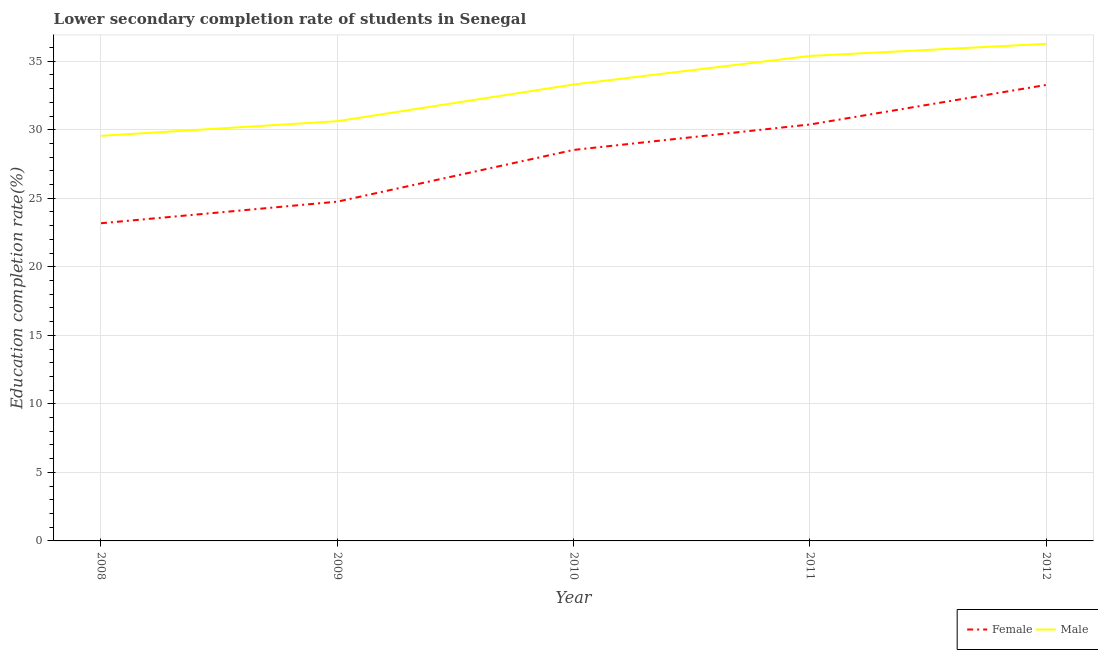How many different coloured lines are there?
Your answer should be compact. 2. Does the line corresponding to education completion rate of female students intersect with the line corresponding to education completion rate of male students?
Keep it short and to the point. No. What is the education completion rate of male students in 2008?
Give a very brief answer. 29.55. Across all years, what is the maximum education completion rate of male students?
Your response must be concise. 36.27. Across all years, what is the minimum education completion rate of male students?
Offer a terse response. 29.55. In which year was the education completion rate of female students maximum?
Your answer should be very brief. 2012. In which year was the education completion rate of female students minimum?
Provide a short and direct response. 2008. What is the total education completion rate of male students in the graph?
Offer a terse response. 165.12. What is the difference between the education completion rate of female students in 2009 and that in 2010?
Your answer should be compact. -3.77. What is the difference between the education completion rate of male students in 2011 and the education completion rate of female students in 2009?
Provide a succinct answer. 10.63. What is the average education completion rate of female students per year?
Ensure brevity in your answer.  28.02. In the year 2008, what is the difference between the education completion rate of male students and education completion rate of female students?
Keep it short and to the point. 6.38. In how many years, is the education completion rate of female students greater than 5 %?
Give a very brief answer. 5. What is the ratio of the education completion rate of female students in 2008 to that in 2012?
Your answer should be compact. 0.7. Is the difference between the education completion rate of male students in 2009 and 2012 greater than the difference between the education completion rate of female students in 2009 and 2012?
Ensure brevity in your answer.  Yes. What is the difference between the highest and the second highest education completion rate of female students?
Keep it short and to the point. 2.89. What is the difference between the highest and the lowest education completion rate of male students?
Offer a terse response. 6.71. Does the education completion rate of female students monotonically increase over the years?
Ensure brevity in your answer.  Yes. Is the education completion rate of male students strictly greater than the education completion rate of female students over the years?
Keep it short and to the point. Yes. How many years are there in the graph?
Your answer should be compact. 5. Are the values on the major ticks of Y-axis written in scientific E-notation?
Give a very brief answer. No. Where does the legend appear in the graph?
Your answer should be compact. Bottom right. How many legend labels are there?
Make the answer very short. 2. How are the legend labels stacked?
Your answer should be very brief. Horizontal. What is the title of the graph?
Give a very brief answer. Lower secondary completion rate of students in Senegal. What is the label or title of the X-axis?
Offer a terse response. Year. What is the label or title of the Y-axis?
Keep it short and to the point. Education completion rate(%). What is the Education completion rate(%) in Female in 2008?
Your answer should be compact. 23.18. What is the Education completion rate(%) in Male in 2008?
Your answer should be compact. 29.55. What is the Education completion rate(%) in Female in 2009?
Ensure brevity in your answer.  24.75. What is the Education completion rate(%) of Male in 2009?
Your response must be concise. 30.62. What is the Education completion rate(%) in Female in 2010?
Your answer should be compact. 28.53. What is the Education completion rate(%) in Male in 2010?
Give a very brief answer. 33.3. What is the Education completion rate(%) in Female in 2011?
Provide a short and direct response. 30.38. What is the Education completion rate(%) in Male in 2011?
Your answer should be compact. 35.38. What is the Education completion rate(%) in Female in 2012?
Give a very brief answer. 33.27. What is the Education completion rate(%) in Male in 2012?
Give a very brief answer. 36.27. Across all years, what is the maximum Education completion rate(%) in Female?
Your answer should be compact. 33.27. Across all years, what is the maximum Education completion rate(%) of Male?
Keep it short and to the point. 36.27. Across all years, what is the minimum Education completion rate(%) of Female?
Give a very brief answer. 23.18. Across all years, what is the minimum Education completion rate(%) of Male?
Make the answer very short. 29.55. What is the total Education completion rate(%) in Female in the graph?
Provide a succinct answer. 140.1. What is the total Education completion rate(%) in Male in the graph?
Offer a very short reply. 165.12. What is the difference between the Education completion rate(%) in Female in 2008 and that in 2009?
Your answer should be compact. -1.57. What is the difference between the Education completion rate(%) in Male in 2008 and that in 2009?
Your answer should be very brief. -1.07. What is the difference between the Education completion rate(%) of Female in 2008 and that in 2010?
Offer a terse response. -5.35. What is the difference between the Education completion rate(%) in Male in 2008 and that in 2010?
Provide a succinct answer. -3.75. What is the difference between the Education completion rate(%) of Female in 2008 and that in 2011?
Your answer should be compact. -7.21. What is the difference between the Education completion rate(%) of Male in 2008 and that in 2011?
Your answer should be very brief. -5.83. What is the difference between the Education completion rate(%) of Female in 2008 and that in 2012?
Offer a terse response. -10.09. What is the difference between the Education completion rate(%) in Male in 2008 and that in 2012?
Make the answer very short. -6.71. What is the difference between the Education completion rate(%) of Female in 2009 and that in 2010?
Ensure brevity in your answer.  -3.77. What is the difference between the Education completion rate(%) of Male in 2009 and that in 2010?
Your response must be concise. -2.68. What is the difference between the Education completion rate(%) in Female in 2009 and that in 2011?
Make the answer very short. -5.63. What is the difference between the Education completion rate(%) in Male in 2009 and that in 2011?
Your answer should be very brief. -4.76. What is the difference between the Education completion rate(%) of Female in 2009 and that in 2012?
Your response must be concise. -8.52. What is the difference between the Education completion rate(%) of Male in 2009 and that in 2012?
Offer a terse response. -5.64. What is the difference between the Education completion rate(%) of Female in 2010 and that in 2011?
Give a very brief answer. -1.86. What is the difference between the Education completion rate(%) in Male in 2010 and that in 2011?
Offer a very short reply. -2.08. What is the difference between the Education completion rate(%) of Female in 2010 and that in 2012?
Provide a short and direct response. -4.74. What is the difference between the Education completion rate(%) in Male in 2010 and that in 2012?
Give a very brief answer. -2.97. What is the difference between the Education completion rate(%) in Female in 2011 and that in 2012?
Ensure brevity in your answer.  -2.89. What is the difference between the Education completion rate(%) of Male in 2011 and that in 2012?
Give a very brief answer. -0.88. What is the difference between the Education completion rate(%) of Female in 2008 and the Education completion rate(%) of Male in 2009?
Keep it short and to the point. -7.45. What is the difference between the Education completion rate(%) of Female in 2008 and the Education completion rate(%) of Male in 2010?
Make the answer very short. -10.12. What is the difference between the Education completion rate(%) in Female in 2008 and the Education completion rate(%) in Male in 2011?
Offer a terse response. -12.21. What is the difference between the Education completion rate(%) in Female in 2008 and the Education completion rate(%) in Male in 2012?
Your response must be concise. -13.09. What is the difference between the Education completion rate(%) in Female in 2009 and the Education completion rate(%) in Male in 2010?
Provide a short and direct response. -8.55. What is the difference between the Education completion rate(%) of Female in 2009 and the Education completion rate(%) of Male in 2011?
Your answer should be very brief. -10.63. What is the difference between the Education completion rate(%) in Female in 2009 and the Education completion rate(%) in Male in 2012?
Keep it short and to the point. -11.51. What is the difference between the Education completion rate(%) of Female in 2010 and the Education completion rate(%) of Male in 2011?
Offer a terse response. -6.86. What is the difference between the Education completion rate(%) in Female in 2010 and the Education completion rate(%) in Male in 2012?
Provide a short and direct response. -7.74. What is the difference between the Education completion rate(%) in Female in 2011 and the Education completion rate(%) in Male in 2012?
Your response must be concise. -5.88. What is the average Education completion rate(%) of Female per year?
Make the answer very short. 28.02. What is the average Education completion rate(%) of Male per year?
Offer a very short reply. 33.02. In the year 2008, what is the difference between the Education completion rate(%) of Female and Education completion rate(%) of Male?
Your answer should be compact. -6.38. In the year 2009, what is the difference between the Education completion rate(%) of Female and Education completion rate(%) of Male?
Your answer should be compact. -5.87. In the year 2010, what is the difference between the Education completion rate(%) in Female and Education completion rate(%) in Male?
Keep it short and to the point. -4.77. In the year 2011, what is the difference between the Education completion rate(%) in Female and Education completion rate(%) in Male?
Give a very brief answer. -5. In the year 2012, what is the difference between the Education completion rate(%) of Female and Education completion rate(%) of Male?
Your answer should be compact. -3. What is the ratio of the Education completion rate(%) in Female in 2008 to that in 2009?
Your answer should be very brief. 0.94. What is the ratio of the Education completion rate(%) in Male in 2008 to that in 2009?
Your response must be concise. 0.97. What is the ratio of the Education completion rate(%) of Female in 2008 to that in 2010?
Keep it short and to the point. 0.81. What is the ratio of the Education completion rate(%) of Male in 2008 to that in 2010?
Make the answer very short. 0.89. What is the ratio of the Education completion rate(%) of Female in 2008 to that in 2011?
Offer a terse response. 0.76. What is the ratio of the Education completion rate(%) of Male in 2008 to that in 2011?
Keep it short and to the point. 0.84. What is the ratio of the Education completion rate(%) in Female in 2008 to that in 2012?
Make the answer very short. 0.7. What is the ratio of the Education completion rate(%) of Male in 2008 to that in 2012?
Offer a terse response. 0.81. What is the ratio of the Education completion rate(%) of Female in 2009 to that in 2010?
Make the answer very short. 0.87. What is the ratio of the Education completion rate(%) in Male in 2009 to that in 2010?
Give a very brief answer. 0.92. What is the ratio of the Education completion rate(%) of Female in 2009 to that in 2011?
Ensure brevity in your answer.  0.81. What is the ratio of the Education completion rate(%) in Male in 2009 to that in 2011?
Provide a short and direct response. 0.87. What is the ratio of the Education completion rate(%) in Female in 2009 to that in 2012?
Provide a short and direct response. 0.74. What is the ratio of the Education completion rate(%) of Male in 2009 to that in 2012?
Keep it short and to the point. 0.84. What is the ratio of the Education completion rate(%) in Female in 2010 to that in 2011?
Offer a terse response. 0.94. What is the ratio of the Education completion rate(%) of Male in 2010 to that in 2011?
Make the answer very short. 0.94. What is the ratio of the Education completion rate(%) in Female in 2010 to that in 2012?
Keep it short and to the point. 0.86. What is the ratio of the Education completion rate(%) in Male in 2010 to that in 2012?
Provide a short and direct response. 0.92. What is the ratio of the Education completion rate(%) of Female in 2011 to that in 2012?
Provide a short and direct response. 0.91. What is the ratio of the Education completion rate(%) of Male in 2011 to that in 2012?
Ensure brevity in your answer.  0.98. What is the difference between the highest and the second highest Education completion rate(%) in Female?
Ensure brevity in your answer.  2.89. What is the difference between the highest and the second highest Education completion rate(%) in Male?
Make the answer very short. 0.88. What is the difference between the highest and the lowest Education completion rate(%) in Female?
Provide a short and direct response. 10.09. What is the difference between the highest and the lowest Education completion rate(%) of Male?
Make the answer very short. 6.71. 